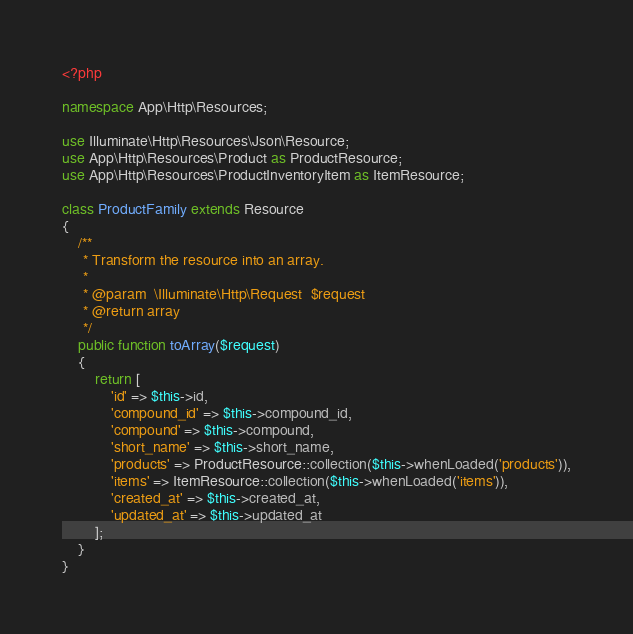Convert code to text. <code><loc_0><loc_0><loc_500><loc_500><_PHP_><?php

namespace App\Http\Resources;

use Illuminate\Http\Resources\Json\Resource;
use App\Http\Resources\Product as ProductResource;
use App\Http\Resources\ProductInventoryItem as ItemResource;

class ProductFamily extends Resource
{
    /**
     * Transform the resource into an array.
     *
     * @param  \Illuminate\Http\Request  $request
     * @return array
     */
    public function toArray($request)
    {
        return [
            'id' => $this->id,
            'compound_id' => $this->compound_id,
            'compound' => $this->compound,
            'short_name' => $this->short_name,
            'products' => ProductResource::collection($this->whenLoaded('products')),
            'items' => ItemResource::collection($this->whenLoaded('items')),
            'created_at' => $this->created_at,
            'updated_at' => $this->updated_at
        ];
    }
}
</code> 